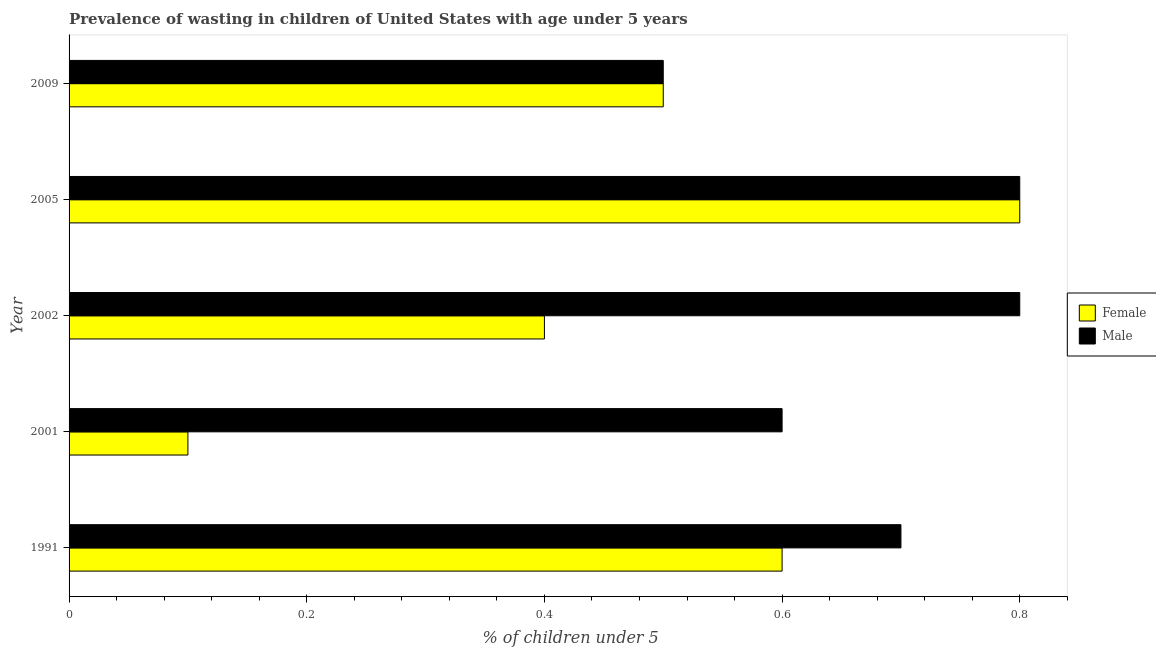Are the number of bars per tick equal to the number of legend labels?
Make the answer very short. Yes. Are the number of bars on each tick of the Y-axis equal?
Provide a short and direct response. Yes. What is the label of the 4th group of bars from the top?
Provide a succinct answer. 2001. In how many cases, is the number of bars for a given year not equal to the number of legend labels?
Offer a terse response. 0. What is the percentage of undernourished female children in 1991?
Give a very brief answer. 0.6. Across all years, what is the maximum percentage of undernourished female children?
Ensure brevity in your answer.  0.8. Across all years, what is the minimum percentage of undernourished female children?
Give a very brief answer. 0.1. In which year was the percentage of undernourished female children maximum?
Keep it short and to the point. 2005. In which year was the percentage of undernourished female children minimum?
Provide a short and direct response. 2001. What is the total percentage of undernourished female children in the graph?
Your answer should be very brief. 2.4. What is the difference between the percentage of undernourished female children in 1991 and that in 2005?
Offer a terse response. -0.2. What is the average percentage of undernourished female children per year?
Your response must be concise. 0.48. In the year 2009, what is the difference between the percentage of undernourished male children and percentage of undernourished female children?
Ensure brevity in your answer.  0. In how many years, is the percentage of undernourished female children greater than 0.8 %?
Give a very brief answer. 1. What is the ratio of the percentage of undernourished female children in 2001 to that in 2009?
Your answer should be very brief. 0.2. Is the percentage of undernourished male children in 2001 less than that in 2009?
Offer a terse response. No. Is the difference between the percentage of undernourished female children in 2002 and 2009 greater than the difference between the percentage of undernourished male children in 2002 and 2009?
Keep it short and to the point. No. What is the difference between the highest and the lowest percentage of undernourished female children?
Provide a succinct answer. 0.7. In how many years, is the percentage of undernourished female children greater than the average percentage of undernourished female children taken over all years?
Give a very brief answer. 3. Is the sum of the percentage of undernourished female children in 1991 and 2002 greater than the maximum percentage of undernourished male children across all years?
Offer a very short reply. Yes. Are all the bars in the graph horizontal?
Make the answer very short. Yes. Are the values on the major ticks of X-axis written in scientific E-notation?
Offer a terse response. No. Does the graph contain any zero values?
Keep it short and to the point. No. Does the graph contain grids?
Give a very brief answer. No. Where does the legend appear in the graph?
Give a very brief answer. Center right. How many legend labels are there?
Offer a very short reply. 2. What is the title of the graph?
Your answer should be very brief. Prevalence of wasting in children of United States with age under 5 years. Does "Import" appear as one of the legend labels in the graph?
Make the answer very short. No. What is the label or title of the X-axis?
Offer a terse response.  % of children under 5. What is the  % of children under 5 in Female in 1991?
Your response must be concise. 0.6. What is the  % of children under 5 of Male in 1991?
Make the answer very short. 0.7. What is the  % of children under 5 of Female in 2001?
Ensure brevity in your answer.  0.1. What is the  % of children under 5 in Male in 2001?
Provide a succinct answer. 0.6. What is the  % of children under 5 of Female in 2002?
Your answer should be compact. 0.4. What is the  % of children under 5 in Male in 2002?
Offer a very short reply. 0.8. What is the  % of children under 5 in Female in 2005?
Give a very brief answer. 0.8. What is the  % of children under 5 of Male in 2005?
Make the answer very short. 0.8. What is the  % of children under 5 in Male in 2009?
Provide a succinct answer. 0.5. Across all years, what is the maximum  % of children under 5 of Female?
Offer a terse response. 0.8. Across all years, what is the maximum  % of children under 5 of Male?
Your answer should be very brief. 0.8. Across all years, what is the minimum  % of children under 5 in Female?
Provide a short and direct response. 0.1. What is the difference between the  % of children under 5 of Female in 1991 and that in 2001?
Make the answer very short. 0.5. What is the difference between the  % of children under 5 of Male in 1991 and that in 2001?
Your answer should be compact. 0.1. What is the difference between the  % of children under 5 in Female in 1991 and that in 2005?
Make the answer very short. -0.2. What is the difference between the  % of children under 5 of Female in 2001 and that in 2002?
Your response must be concise. -0.3. What is the difference between the  % of children under 5 of Male in 2001 and that in 2002?
Provide a short and direct response. -0.2. What is the difference between the  % of children under 5 in Male in 2001 and that in 2009?
Make the answer very short. 0.1. What is the difference between the  % of children under 5 in Female in 2002 and that in 2005?
Provide a short and direct response. -0.4. What is the difference between the  % of children under 5 in Male in 2002 and that in 2005?
Provide a short and direct response. 0. What is the difference between the  % of children under 5 in Female in 2002 and that in 2009?
Give a very brief answer. -0.1. What is the difference between the  % of children under 5 in Male in 2002 and that in 2009?
Offer a very short reply. 0.3. What is the difference between the  % of children under 5 of Female in 1991 and the  % of children under 5 of Male in 2002?
Provide a short and direct response. -0.2. What is the difference between the  % of children under 5 in Female in 1991 and the  % of children under 5 in Male in 2009?
Keep it short and to the point. 0.1. What is the difference between the  % of children under 5 of Female in 2001 and the  % of children under 5 of Male in 2002?
Your answer should be very brief. -0.7. What is the difference between the  % of children under 5 in Female in 2001 and the  % of children under 5 in Male in 2005?
Your response must be concise. -0.7. What is the difference between the  % of children under 5 of Female in 2002 and the  % of children under 5 of Male in 2005?
Ensure brevity in your answer.  -0.4. What is the difference between the  % of children under 5 in Female in 2002 and the  % of children under 5 in Male in 2009?
Give a very brief answer. -0.1. What is the difference between the  % of children under 5 in Female in 2005 and the  % of children under 5 in Male in 2009?
Provide a short and direct response. 0.3. What is the average  % of children under 5 of Female per year?
Your response must be concise. 0.48. What is the average  % of children under 5 of Male per year?
Provide a succinct answer. 0.68. In the year 2005, what is the difference between the  % of children under 5 in Female and  % of children under 5 in Male?
Ensure brevity in your answer.  0. What is the ratio of the  % of children under 5 of Male in 1991 to that in 2001?
Your answer should be very brief. 1.17. What is the ratio of the  % of children under 5 of Male in 1991 to that in 2002?
Provide a short and direct response. 0.88. What is the ratio of the  % of children under 5 of Female in 2001 to that in 2002?
Make the answer very short. 0.25. What is the ratio of the  % of children under 5 of Female in 2001 to that in 2005?
Offer a very short reply. 0.12. What is the ratio of the  % of children under 5 of Male in 2001 to that in 2005?
Keep it short and to the point. 0.75. What is the ratio of the  % of children under 5 in Female in 2001 to that in 2009?
Your answer should be very brief. 0.2. What is the ratio of the  % of children under 5 in Female in 2002 to that in 2005?
Your answer should be compact. 0.5. What is the ratio of the  % of children under 5 in Female in 2002 to that in 2009?
Ensure brevity in your answer.  0.8. What is the difference between the highest and the second highest  % of children under 5 of Male?
Make the answer very short. 0. What is the difference between the highest and the lowest  % of children under 5 in Female?
Offer a terse response. 0.7. What is the difference between the highest and the lowest  % of children under 5 of Male?
Give a very brief answer. 0.3. 